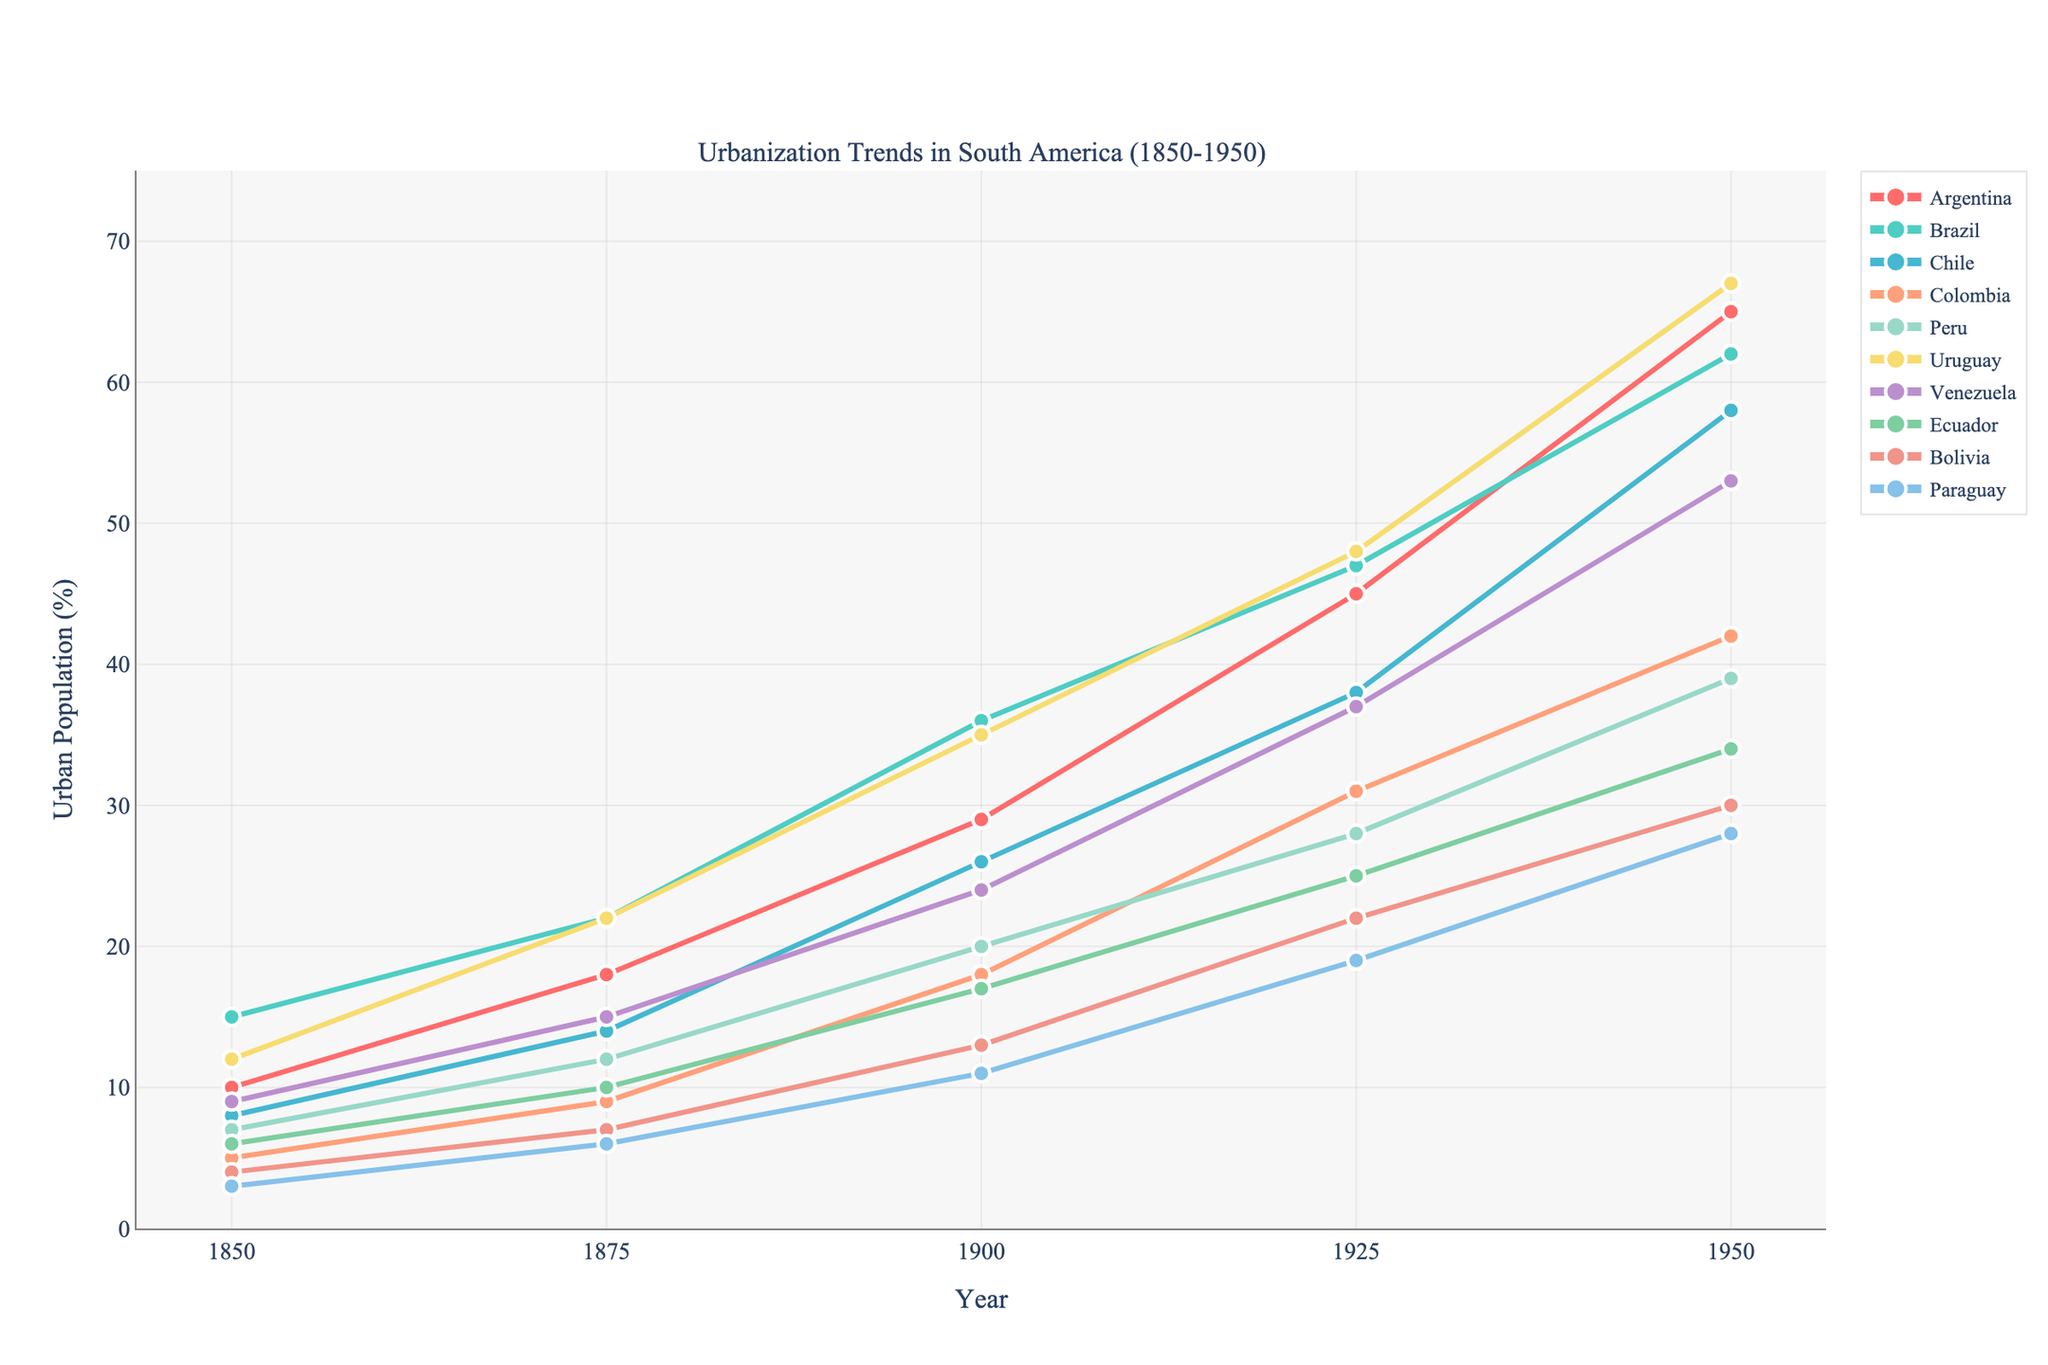Which country had the highest urban population percentage in 1950? The figure shows the urban population percentages for various South American countries in 1950. By comparing the highest points in 1950, we can see the highest percentage was for Uruguay.
Answer: Uruguay Which countries had urban population trends that crossed around 1925? By examining where the lines intersect around 1925, the urbanization trends for Argentina and Brazil crossed at around this year.
Answer: Argentina and Brazil What was the average urban population percentage for Chile from 1850 to 1950? To compute the average, sum the values for Chile (8 + 14 + 26 + 38 + 58) and divide by the number of data points (5). The calculation is (8 + 14 + 26 + 38 + 58) / 5 = 28.8
Answer: 28.8 Which country had a greater urban population percentage in 1925, Peru or Venezuela? By checking the values for both countries in 1925, Peru had 28% and Venezuela had 37%, so Venezuela had a greater percentage.
Answer: Venezuela Which country had the least urban population percentage in 1850 and what was the value? The figure shows the urban population percentages in 1850. The smallest value can be found for Paraguay, indicating it had the least urban population percentage at 3%.
Answer: Paraguay, 3% By how much did the urban population percentage in Colombia increase between 1850 and 1950? Subtract the value for Colombia in 1850 (5%) from the value in 1950 (42%) to find the increase: 42 - 5 = 37.
Answer: 37% What was the difference in urban population percentage between Brazil and Bolivia in 1950? Subtract the value for Bolivia in 1950 (30%) from the value for Brazil in 1950 (62%): 62 - 30 = 32.
Answer: 32 Which country's urban population percentage saw the steepest increase between 1900 and 1950? By comparing the slopes (steepness) of the lines from 1900 to 1950, the steepest increase is seen for Chile, clearly ascending from 26% to 58%.
Answer: Chile How does the urban population growth pattern in Argentina compare to that in Ecuador from 1850 to 1950? Argentina shows a more rapid and steady increase from 10% to 65%, whereas Ecuador exhibits a more gradual growth from 6% to 34%.
Answer: Argentina's growth is rapid and steady; Ecuador's is gradual 